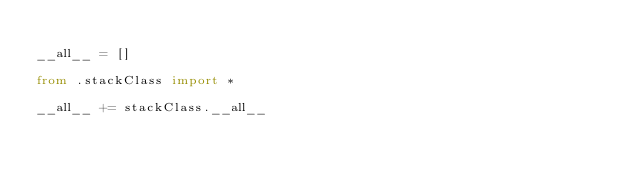Convert code to text. <code><loc_0><loc_0><loc_500><loc_500><_Python_>
__all__ = []

from .stackClass import *

__all__ += stackClass.__all__</code> 